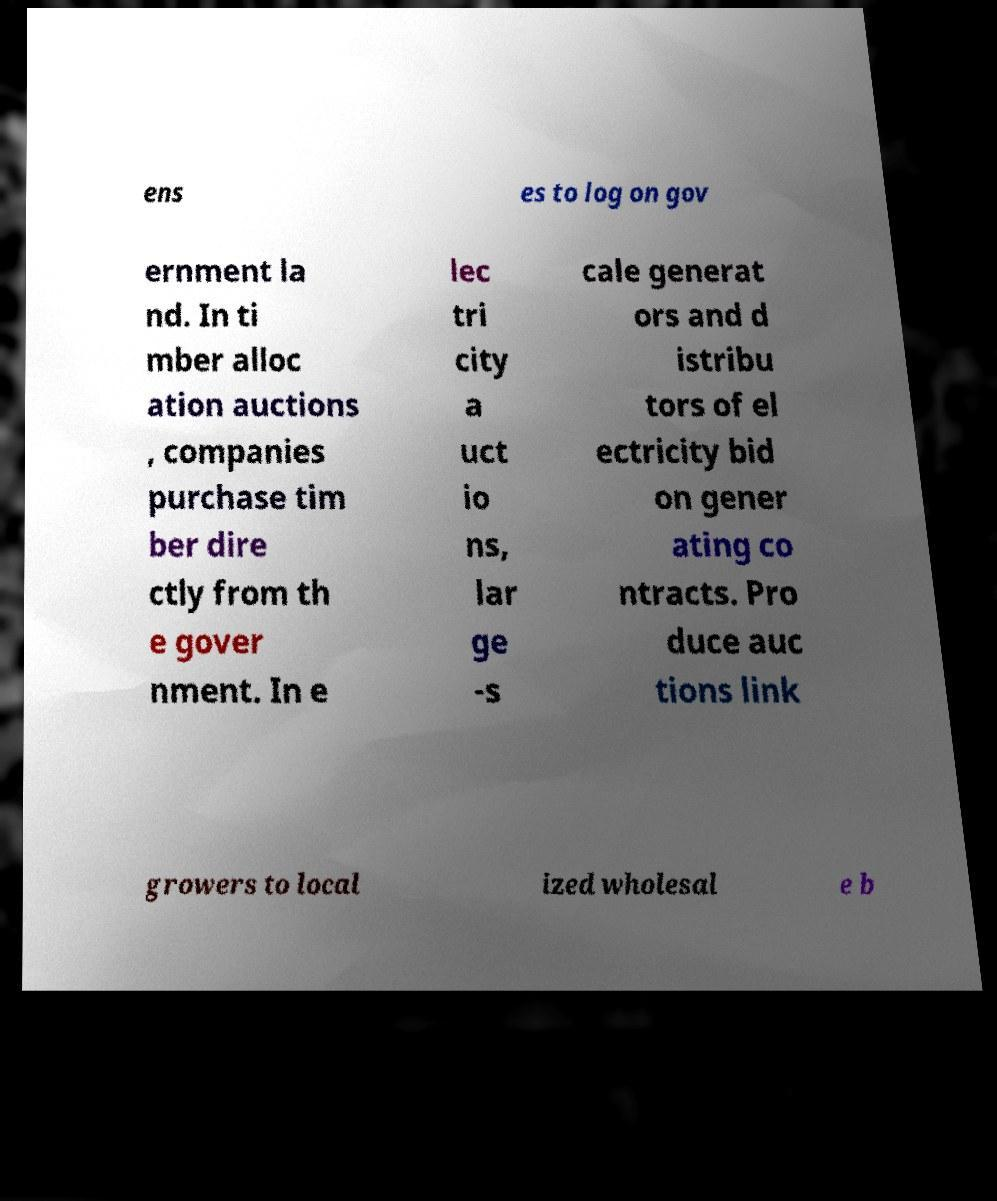I need the written content from this picture converted into text. Can you do that? ens es to log on gov ernment la nd. In ti mber alloc ation auctions , companies purchase tim ber dire ctly from th e gover nment. In e lec tri city a uct io ns, lar ge -s cale generat ors and d istribu tors of el ectricity bid on gener ating co ntracts. Pro duce auc tions link growers to local ized wholesal e b 